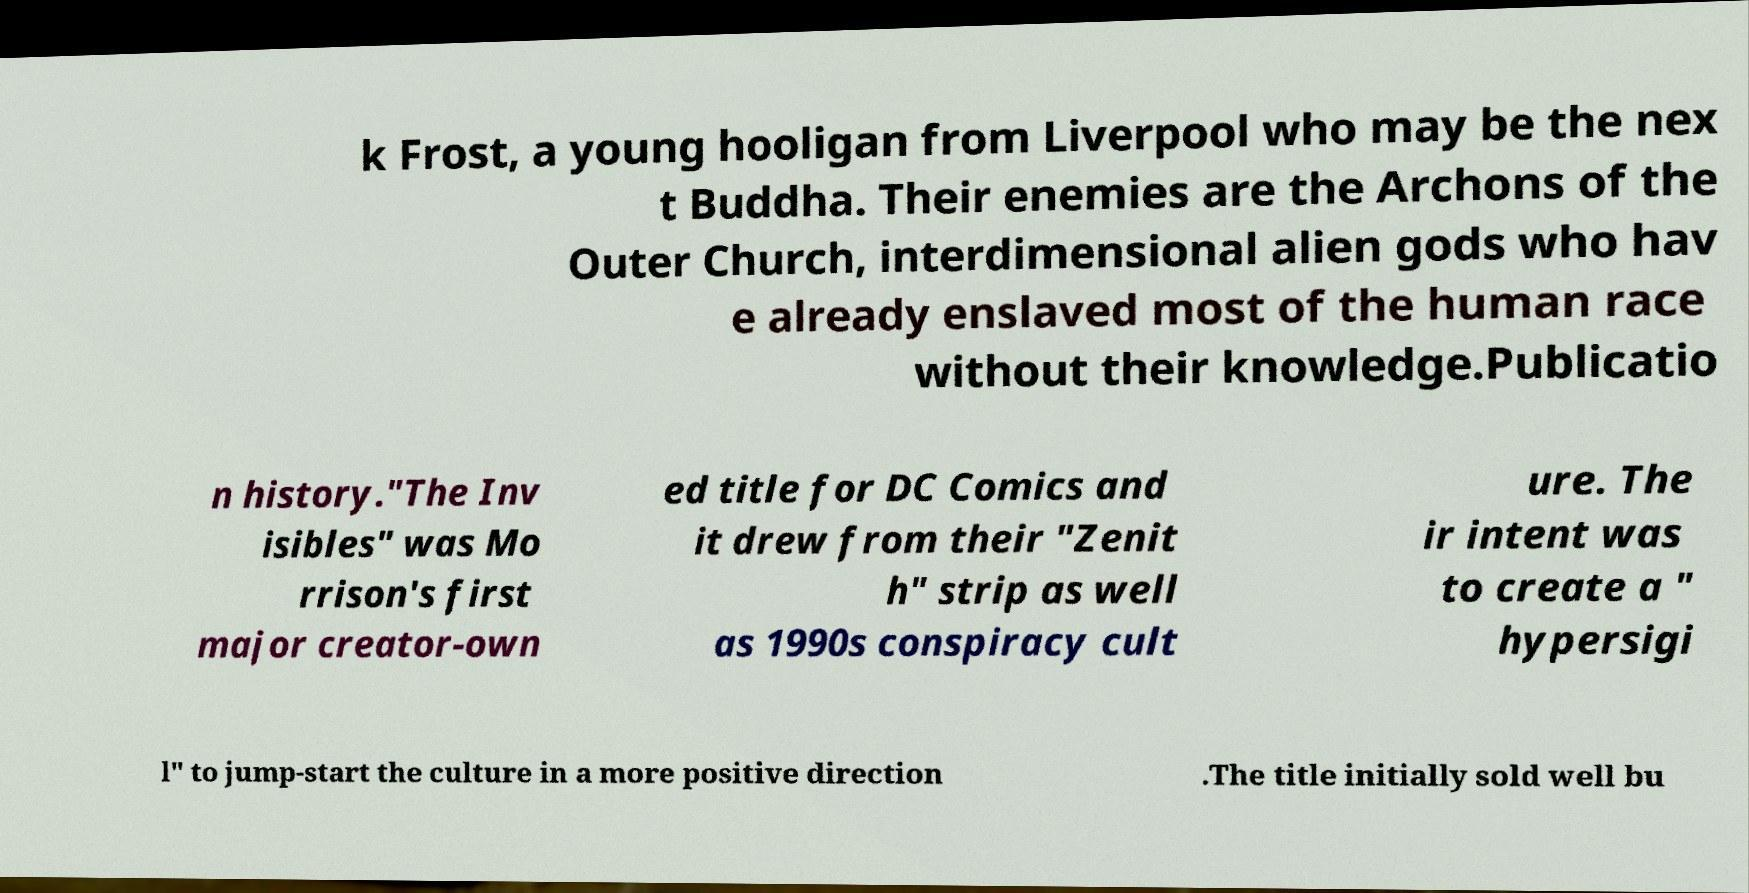Can you accurately transcribe the text from the provided image for me? k Frost, a young hooligan from Liverpool who may be the nex t Buddha. Their enemies are the Archons of the Outer Church, interdimensional alien gods who hav e already enslaved most of the human race without their knowledge.Publicatio n history."The Inv isibles" was Mo rrison's first major creator-own ed title for DC Comics and it drew from their "Zenit h" strip as well as 1990s conspiracy cult ure. The ir intent was to create a " hypersigi l" to jump-start the culture in a more positive direction .The title initially sold well bu 